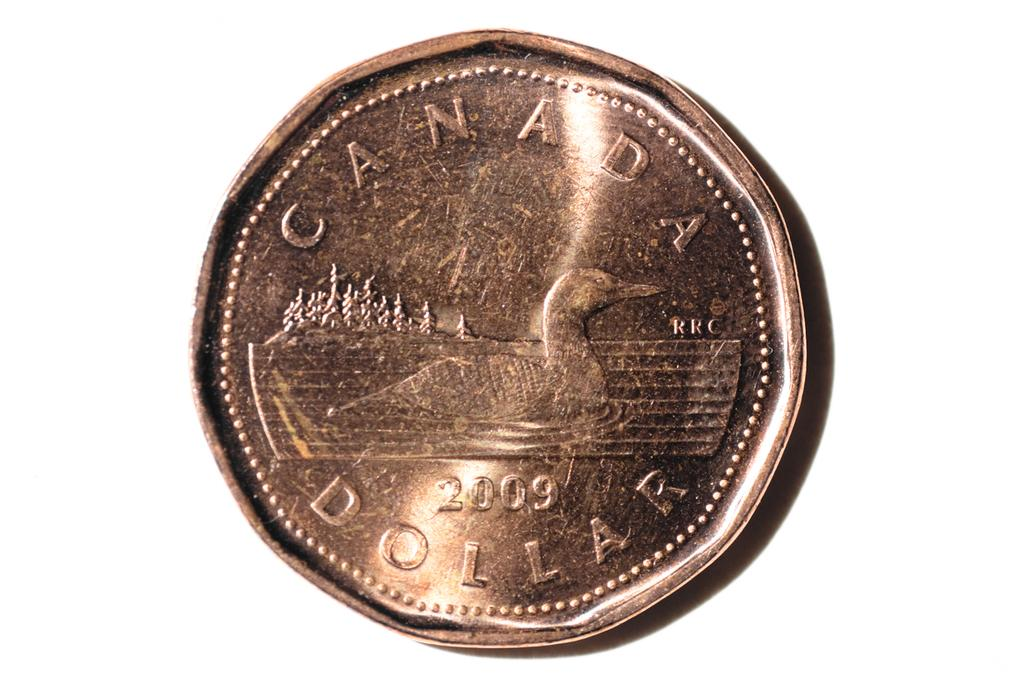<image>
Relay a brief, clear account of the picture shown. The Canada Dollar will one day be considered a collectible. 